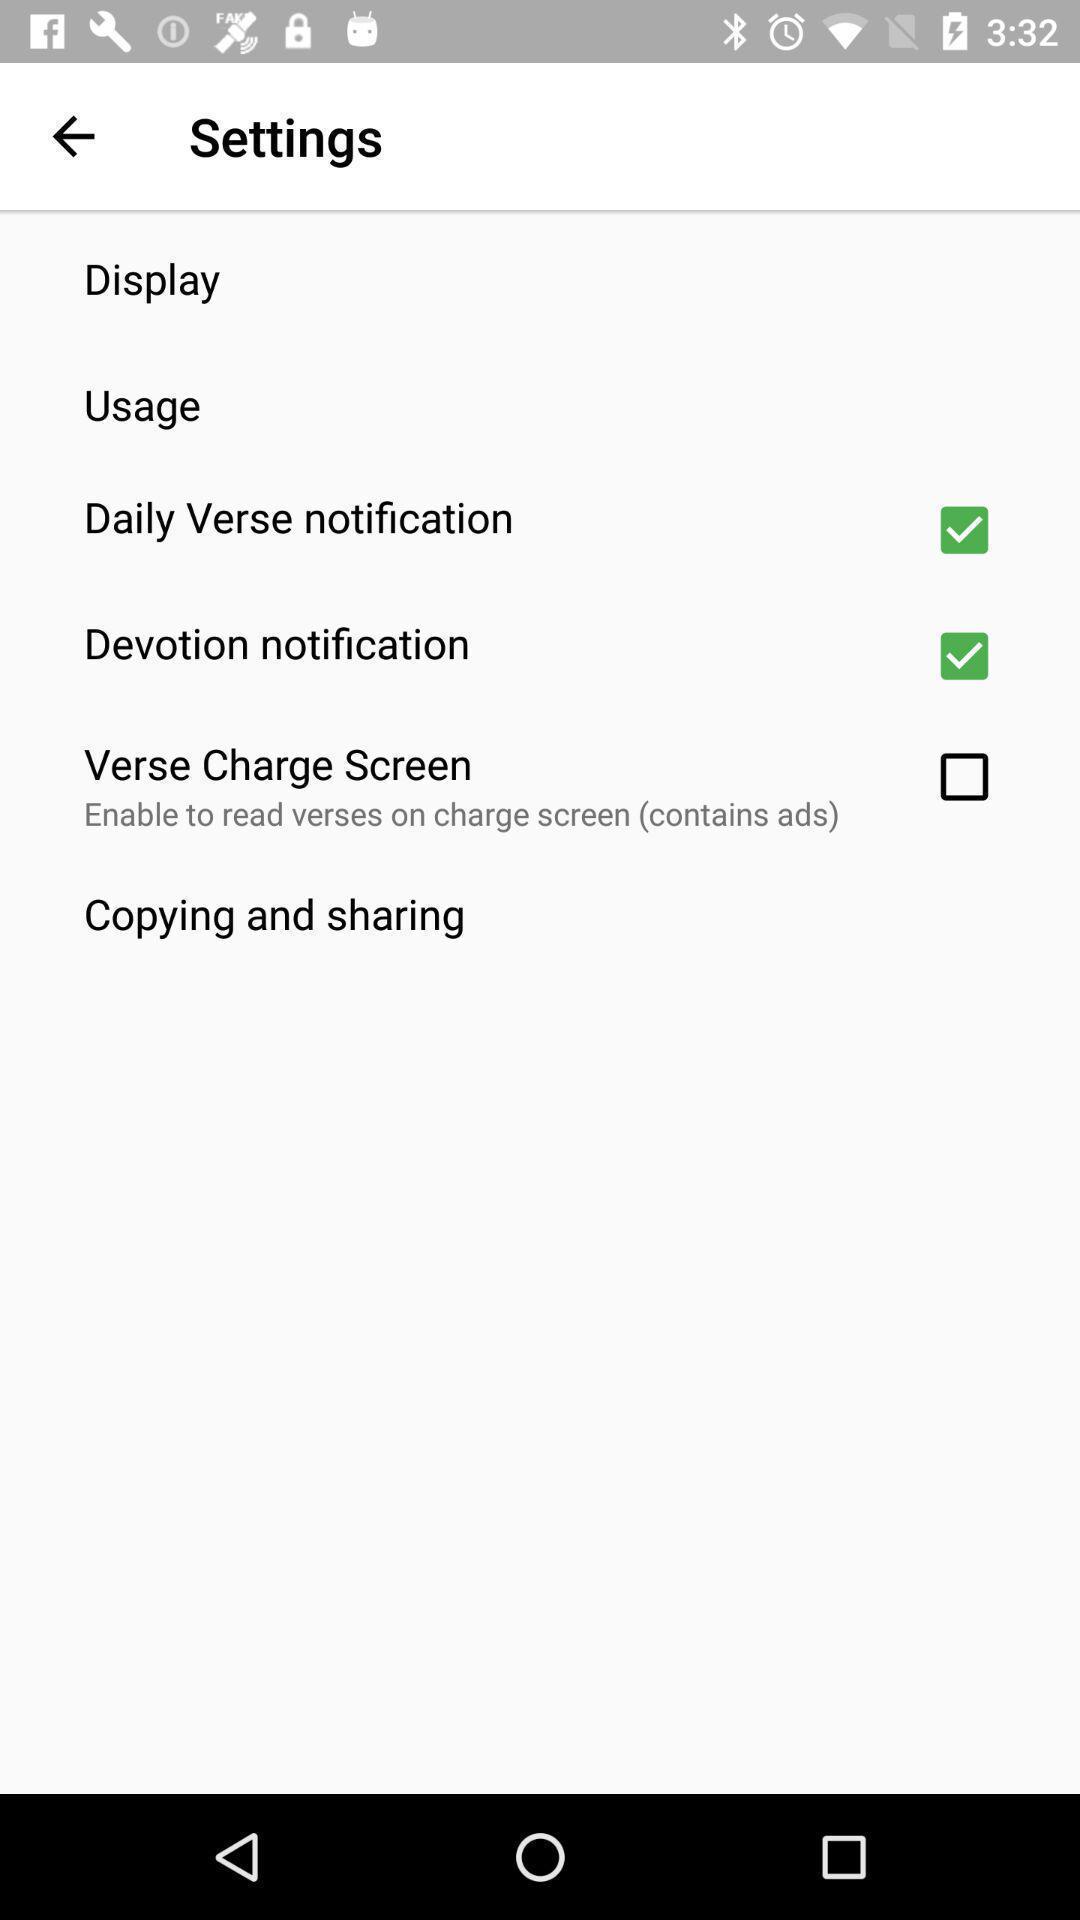Describe the visual elements of this screenshot. Setting page displaying various options. 